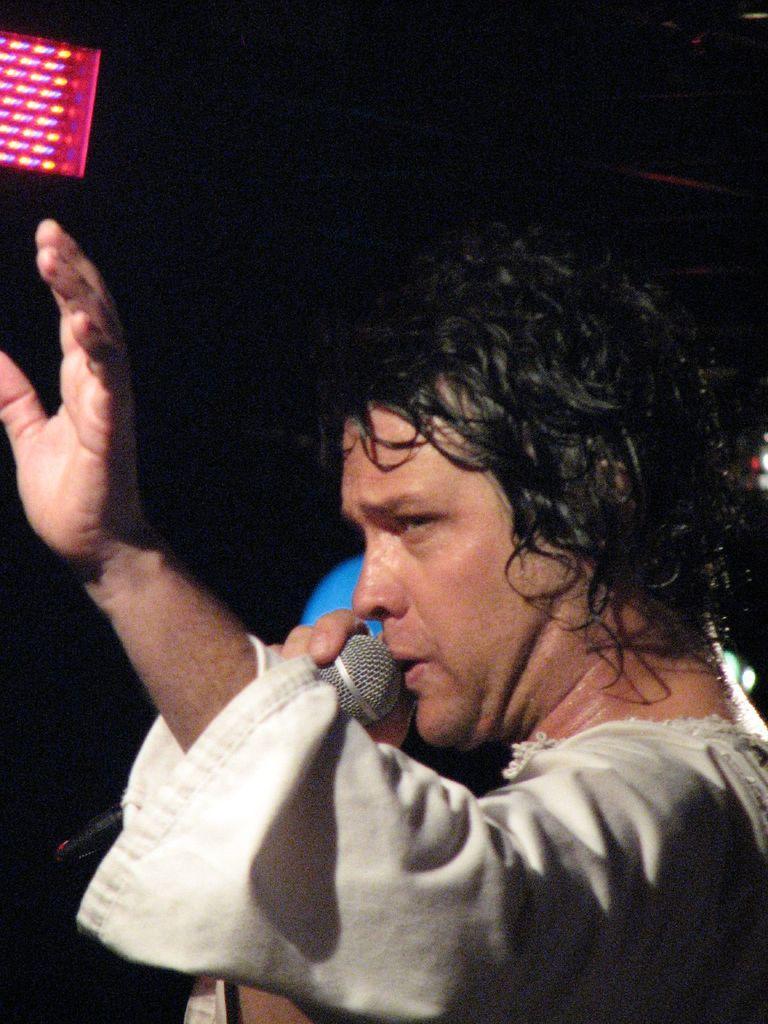How would you summarize this image in a sentence or two? In this picture we can see a man holding a microphone, on the left side there is a light, we can see a dark background. 